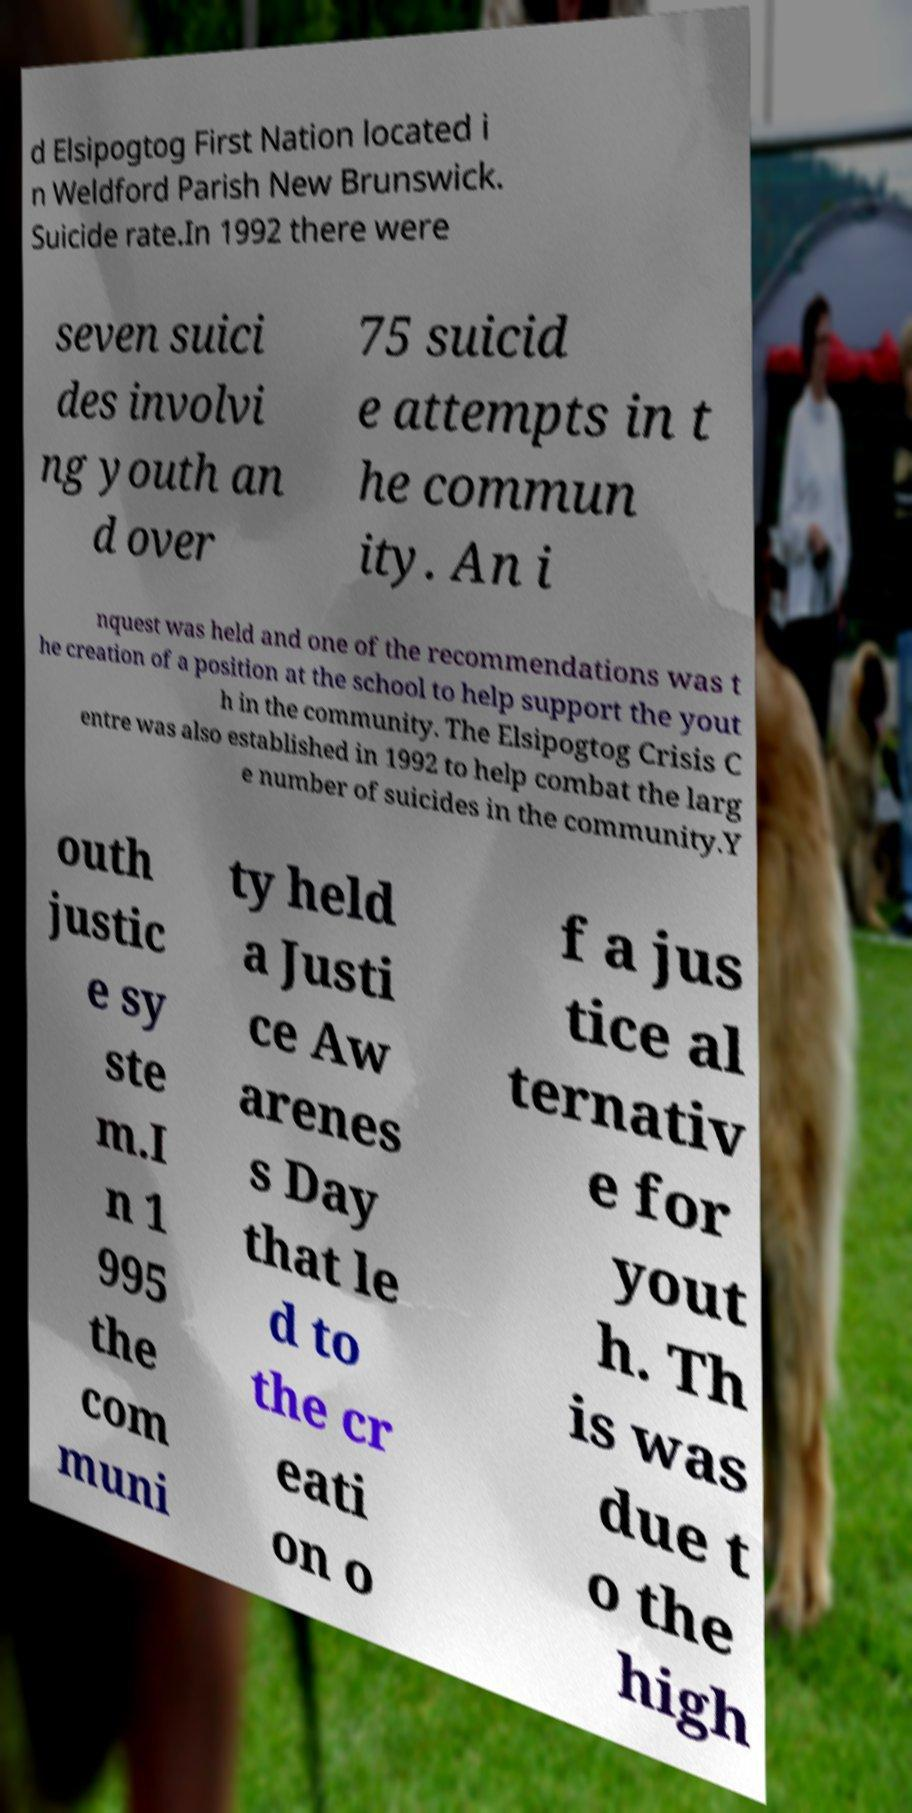I need the written content from this picture converted into text. Can you do that? d Elsipogtog First Nation located i n Weldford Parish New Brunswick. Suicide rate.In 1992 there were seven suici des involvi ng youth an d over 75 suicid e attempts in t he commun ity. An i nquest was held and one of the recommendations was t he creation of a position at the school to help support the yout h in the community. The Elsipogtog Crisis C entre was also established in 1992 to help combat the larg e number of suicides in the community.Y outh justic e sy ste m.I n 1 995 the com muni ty held a Justi ce Aw arenes s Day that le d to the cr eati on o f a jus tice al ternativ e for yout h. Th is was due t o the high 